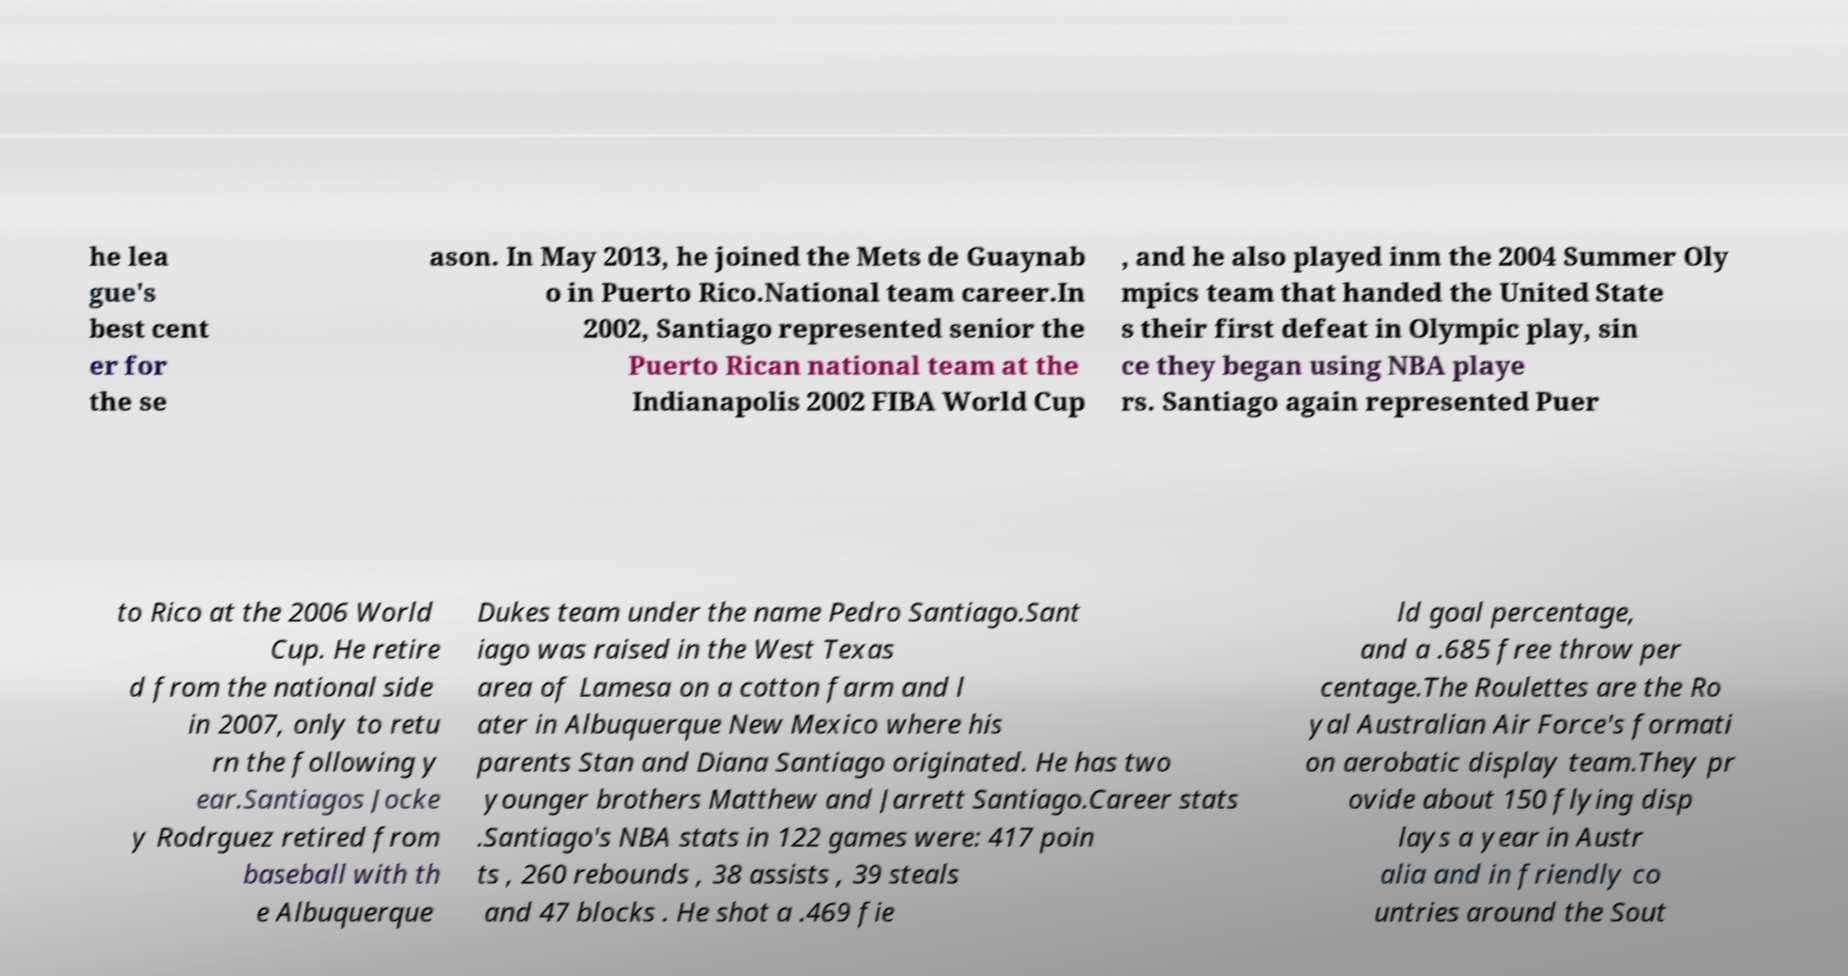There's text embedded in this image that I need extracted. Can you transcribe it verbatim? he lea gue's best cent er for the se ason. In May 2013, he joined the Mets de Guaynab o in Puerto Rico.National team career.In 2002, Santiago represented senior the Puerto Rican national team at the Indianapolis 2002 FIBA World Cup , and he also played inm the 2004 Summer Oly mpics team that handed the United State s their first defeat in Olympic play, sin ce they began using NBA playe rs. Santiago again represented Puer to Rico at the 2006 World Cup. He retire d from the national side in 2007, only to retu rn the following y ear.Santiagos Jocke y Rodrguez retired from baseball with th e Albuquerque Dukes team under the name Pedro Santiago.Sant iago was raised in the West Texas area of Lamesa on a cotton farm and l ater in Albuquerque New Mexico where his parents Stan and Diana Santiago originated. He has two younger brothers Matthew and Jarrett Santiago.Career stats .Santiago's NBA stats in 122 games were: 417 poin ts , 260 rebounds , 38 assists , 39 steals and 47 blocks . He shot a .469 fie ld goal percentage, and a .685 free throw per centage.The Roulettes are the Ro yal Australian Air Force's formati on aerobatic display team.They pr ovide about 150 flying disp lays a year in Austr alia and in friendly co untries around the Sout 